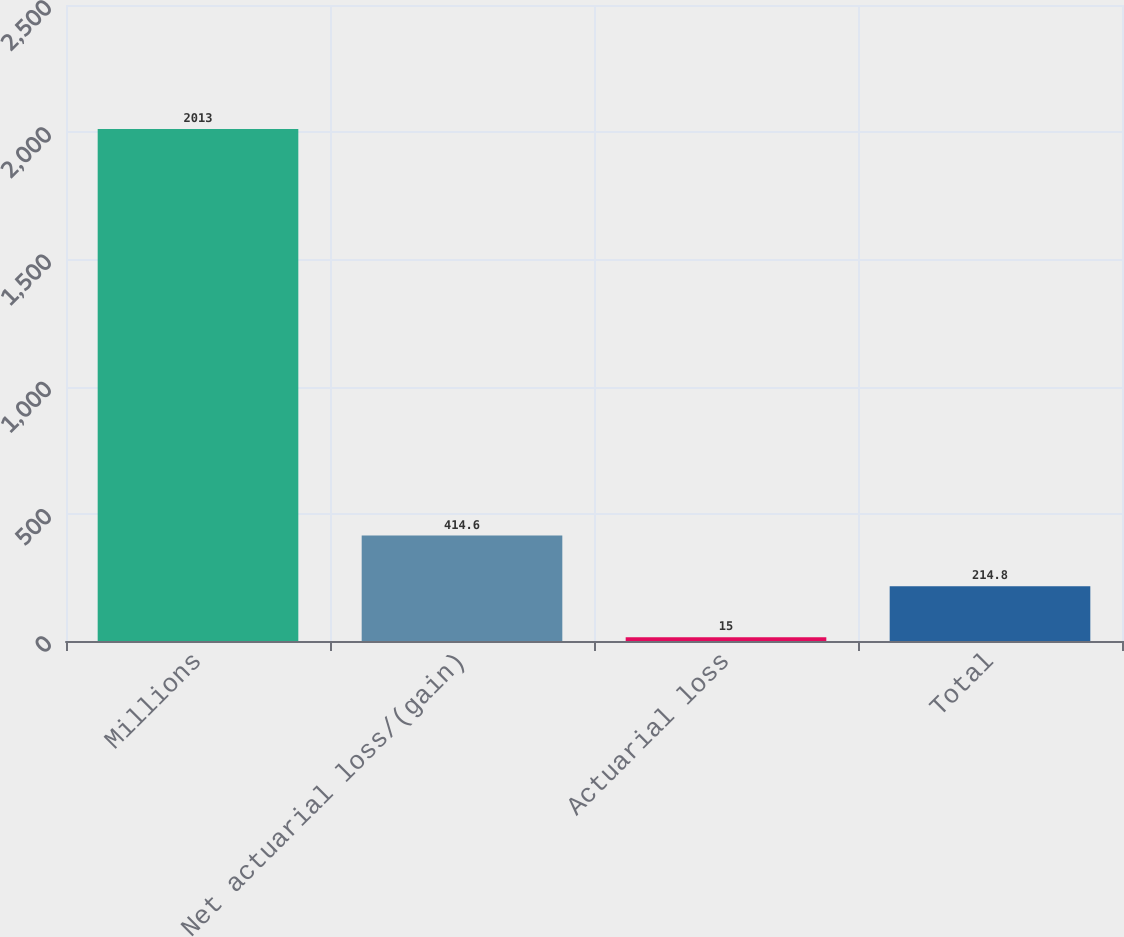Convert chart to OTSL. <chart><loc_0><loc_0><loc_500><loc_500><bar_chart><fcel>Millions<fcel>Net actuarial loss/(gain)<fcel>Actuarial loss<fcel>Total<nl><fcel>2013<fcel>414.6<fcel>15<fcel>214.8<nl></chart> 